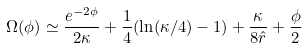<formula> <loc_0><loc_0><loc_500><loc_500>\Omega ( \phi ) \simeq \frac { e ^ { - 2 \phi } } { 2 \kappa } + \frac { 1 } { 4 } ( \ln ( \kappa / 4 ) - 1 ) + \frac { \kappa } { 8 \hat { r } } + \frac { \phi } { 2 }</formula> 